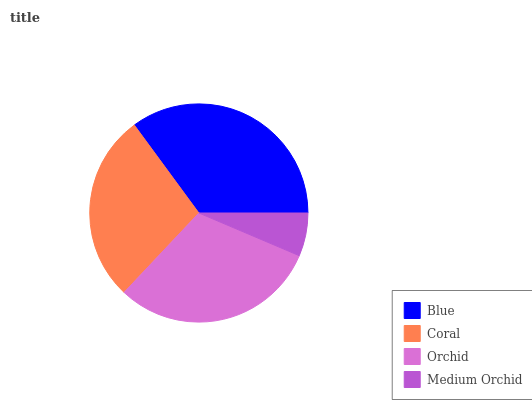Is Medium Orchid the minimum?
Answer yes or no. Yes. Is Blue the maximum?
Answer yes or no. Yes. Is Coral the minimum?
Answer yes or no. No. Is Coral the maximum?
Answer yes or no. No. Is Blue greater than Coral?
Answer yes or no. Yes. Is Coral less than Blue?
Answer yes or no. Yes. Is Coral greater than Blue?
Answer yes or no. No. Is Blue less than Coral?
Answer yes or no. No. Is Orchid the high median?
Answer yes or no. Yes. Is Coral the low median?
Answer yes or no. Yes. Is Coral the high median?
Answer yes or no. No. Is Blue the low median?
Answer yes or no. No. 